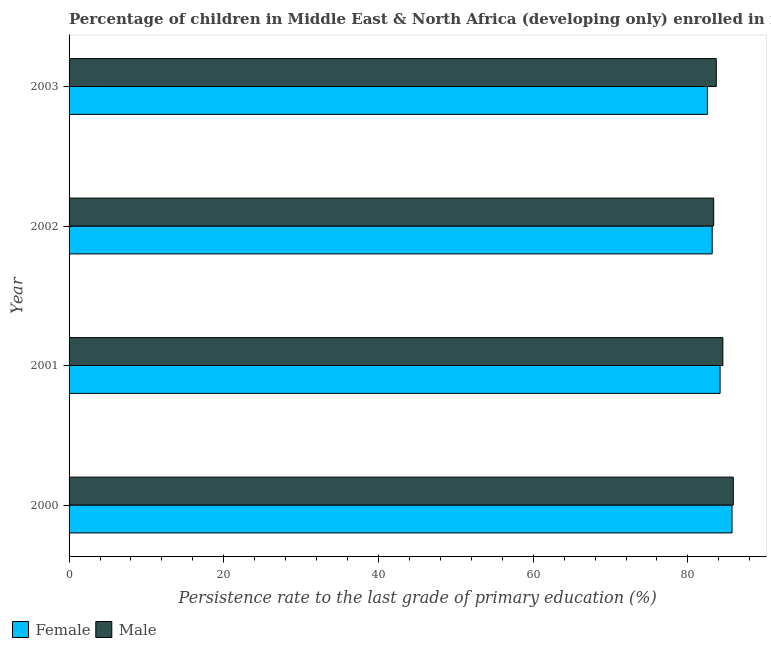How many different coloured bars are there?
Ensure brevity in your answer.  2. Are the number of bars per tick equal to the number of legend labels?
Ensure brevity in your answer.  Yes. Are the number of bars on each tick of the Y-axis equal?
Offer a very short reply. Yes. How many bars are there on the 4th tick from the top?
Your answer should be compact. 2. In how many cases, is the number of bars for a given year not equal to the number of legend labels?
Provide a short and direct response. 0. What is the persistence rate of female students in 2003?
Your answer should be very brief. 82.53. Across all years, what is the maximum persistence rate of male students?
Your answer should be compact. 85.87. Across all years, what is the minimum persistence rate of female students?
Your answer should be very brief. 82.53. In which year was the persistence rate of female students maximum?
Give a very brief answer. 2000. In which year was the persistence rate of male students minimum?
Your answer should be compact. 2002. What is the total persistence rate of male students in the graph?
Offer a terse response. 337.39. What is the difference between the persistence rate of male students in 2000 and that in 2003?
Provide a succinct answer. 2.2. What is the difference between the persistence rate of male students in 2002 and the persistence rate of female students in 2001?
Your response must be concise. -0.83. What is the average persistence rate of male students per year?
Keep it short and to the point. 84.35. In the year 2002, what is the difference between the persistence rate of male students and persistence rate of female students?
Ensure brevity in your answer.  0.19. Is the difference between the persistence rate of male students in 2000 and 2001 greater than the difference between the persistence rate of female students in 2000 and 2001?
Your answer should be compact. No. What is the difference between the highest and the second highest persistence rate of female students?
Give a very brief answer. 1.54. What is the difference between the highest and the lowest persistence rate of male students?
Provide a succinct answer. 2.54. Is the sum of the persistence rate of female students in 2000 and 2003 greater than the maximum persistence rate of male students across all years?
Your response must be concise. Yes. What does the 1st bar from the bottom in 2003 represents?
Ensure brevity in your answer.  Female. How many bars are there?
Ensure brevity in your answer.  8. Are all the bars in the graph horizontal?
Offer a terse response. Yes. Does the graph contain any zero values?
Provide a succinct answer. No. Where does the legend appear in the graph?
Your answer should be very brief. Bottom left. What is the title of the graph?
Offer a very short reply. Percentage of children in Middle East & North Africa (developing only) enrolled in first grade who reached the last grade of primary education. Does "Diesel" appear as one of the legend labels in the graph?
Ensure brevity in your answer.  No. What is the label or title of the X-axis?
Offer a terse response. Persistence rate to the last grade of primary education (%). What is the label or title of the Y-axis?
Your answer should be compact. Year. What is the Persistence rate to the last grade of primary education (%) of Female in 2000?
Offer a very short reply. 85.71. What is the Persistence rate to the last grade of primary education (%) in Male in 2000?
Provide a short and direct response. 85.87. What is the Persistence rate to the last grade of primary education (%) in Female in 2001?
Offer a terse response. 84.17. What is the Persistence rate to the last grade of primary education (%) of Male in 2001?
Your answer should be very brief. 84.52. What is the Persistence rate to the last grade of primary education (%) of Female in 2002?
Provide a succinct answer. 83.14. What is the Persistence rate to the last grade of primary education (%) in Male in 2002?
Provide a short and direct response. 83.33. What is the Persistence rate to the last grade of primary education (%) of Female in 2003?
Keep it short and to the point. 82.53. What is the Persistence rate to the last grade of primary education (%) in Male in 2003?
Your response must be concise. 83.67. Across all years, what is the maximum Persistence rate to the last grade of primary education (%) in Female?
Provide a succinct answer. 85.71. Across all years, what is the maximum Persistence rate to the last grade of primary education (%) of Male?
Your response must be concise. 85.87. Across all years, what is the minimum Persistence rate to the last grade of primary education (%) of Female?
Your answer should be very brief. 82.53. Across all years, what is the minimum Persistence rate to the last grade of primary education (%) in Male?
Offer a very short reply. 83.33. What is the total Persistence rate to the last grade of primary education (%) in Female in the graph?
Your answer should be very brief. 335.54. What is the total Persistence rate to the last grade of primary education (%) in Male in the graph?
Offer a very short reply. 337.39. What is the difference between the Persistence rate to the last grade of primary education (%) in Female in 2000 and that in 2001?
Offer a terse response. 1.54. What is the difference between the Persistence rate to the last grade of primary education (%) in Male in 2000 and that in 2001?
Give a very brief answer. 1.35. What is the difference between the Persistence rate to the last grade of primary education (%) in Female in 2000 and that in 2002?
Your answer should be compact. 2.57. What is the difference between the Persistence rate to the last grade of primary education (%) of Male in 2000 and that in 2002?
Offer a very short reply. 2.54. What is the difference between the Persistence rate to the last grade of primary education (%) in Female in 2000 and that in 2003?
Your answer should be very brief. 3.18. What is the difference between the Persistence rate to the last grade of primary education (%) in Male in 2000 and that in 2003?
Offer a very short reply. 2.2. What is the difference between the Persistence rate to the last grade of primary education (%) of Female in 2001 and that in 2002?
Give a very brief answer. 1.02. What is the difference between the Persistence rate to the last grade of primary education (%) of Male in 2001 and that in 2002?
Offer a terse response. 1.19. What is the difference between the Persistence rate to the last grade of primary education (%) of Female in 2001 and that in 2003?
Provide a succinct answer. 1.64. What is the difference between the Persistence rate to the last grade of primary education (%) of Male in 2001 and that in 2003?
Offer a very short reply. 0.85. What is the difference between the Persistence rate to the last grade of primary education (%) of Female in 2002 and that in 2003?
Offer a terse response. 0.61. What is the difference between the Persistence rate to the last grade of primary education (%) in Male in 2002 and that in 2003?
Your answer should be compact. -0.34. What is the difference between the Persistence rate to the last grade of primary education (%) in Female in 2000 and the Persistence rate to the last grade of primary education (%) in Male in 2001?
Your answer should be compact. 1.19. What is the difference between the Persistence rate to the last grade of primary education (%) in Female in 2000 and the Persistence rate to the last grade of primary education (%) in Male in 2002?
Provide a short and direct response. 2.37. What is the difference between the Persistence rate to the last grade of primary education (%) of Female in 2000 and the Persistence rate to the last grade of primary education (%) of Male in 2003?
Provide a succinct answer. 2.04. What is the difference between the Persistence rate to the last grade of primary education (%) of Female in 2001 and the Persistence rate to the last grade of primary education (%) of Male in 2002?
Offer a terse response. 0.83. What is the difference between the Persistence rate to the last grade of primary education (%) of Female in 2001 and the Persistence rate to the last grade of primary education (%) of Male in 2003?
Your response must be concise. 0.49. What is the difference between the Persistence rate to the last grade of primary education (%) in Female in 2002 and the Persistence rate to the last grade of primary education (%) in Male in 2003?
Keep it short and to the point. -0.53. What is the average Persistence rate to the last grade of primary education (%) in Female per year?
Ensure brevity in your answer.  83.89. What is the average Persistence rate to the last grade of primary education (%) in Male per year?
Your answer should be compact. 84.35. In the year 2000, what is the difference between the Persistence rate to the last grade of primary education (%) in Female and Persistence rate to the last grade of primary education (%) in Male?
Give a very brief answer. -0.16. In the year 2001, what is the difference between the Persistence rate to the last grade of primary education (%) of Female and Persistence rate to the last grade of primary education (%) of Male?
Ensure brevity in your answer.  -0.36. In the year 2002, what is the difference between the Persistence rate to the last grade of primary education (%) of Female and Persistence rate to the last grade of primary education (%) of Male?
Offer a terse response. -0.19. In the year 2003, what is the difference between the Persistence rate to the last grade of primary education (%) of Female and Persistence rate to the last grade of primary education (%) of Male?
Offer a very short reply. -1.14. What is the ratio of the Persistence rate to the last grade of primary education (%) of Female in 2000 to that in 2001?
Offer a very short reply. 1.02. What is the ratio of the Persistence rate to the last grade of primary education (%) of Male in 2000 to that in 2001?
Keep it short and to the point. 1.02. What is the ratio of the Persistence rate to the last grade of primary education (%) in Female in 2000 to that in 2002?
Offer a terse response. 1.03. What is the ratio of the Persistence rate to the last grade of primary education (%) in Male in 2000 to that in 2002?
Your response must be concise. 1.03. What is the ratio of the Persistence rate to the last grade of primary education (%) of Male in 2000 to that in 2003?
Offer a very short reply. 1.03. What is the ratio of the Persistence rate to the last grade of primary education (%) in Female in 2001 to that in 2002?
Your response must be concise. 1.01. What is the ratio of the Persistence rate to the last grade of primary education (%) in Male in 2001 to that in 2002?
Provide a succinct answer. 1.01. What is the ratio of the Persistence rate to the last grade of primary education (%) in Female in 2001 to that in 2003?
Offer a terse response. 1.02. What is the ratio of the Persistence rate to the last grade of primary education (%) of Male in 2001 to that in 2003?
Offer a terse response. 1.01. What is the ratio of the Persistence rate to the last grade of primary education (%) of Female in 2002 to that in 2003?
Your answer should be compact. 1.01. What is the difference between the highest and the second highest Persistence rate to the last grade of primary education (%) of Female?
Offer a terse response. 1.54. What is the difference between the highest and the second highest Persistence rate to the last grade of primary education (%) of Male?
Offer a very short reply. 1.35. What is the difference between the highest and the lowest Persistence rate to the last grade of primary education (%) in Female?
Ensure brevity in your answer.  3.18. What is the difference between the highest and the lowest Persistence rate to the last grade of primary education (%) of Male?
Offer a very short reply. 2.54. 